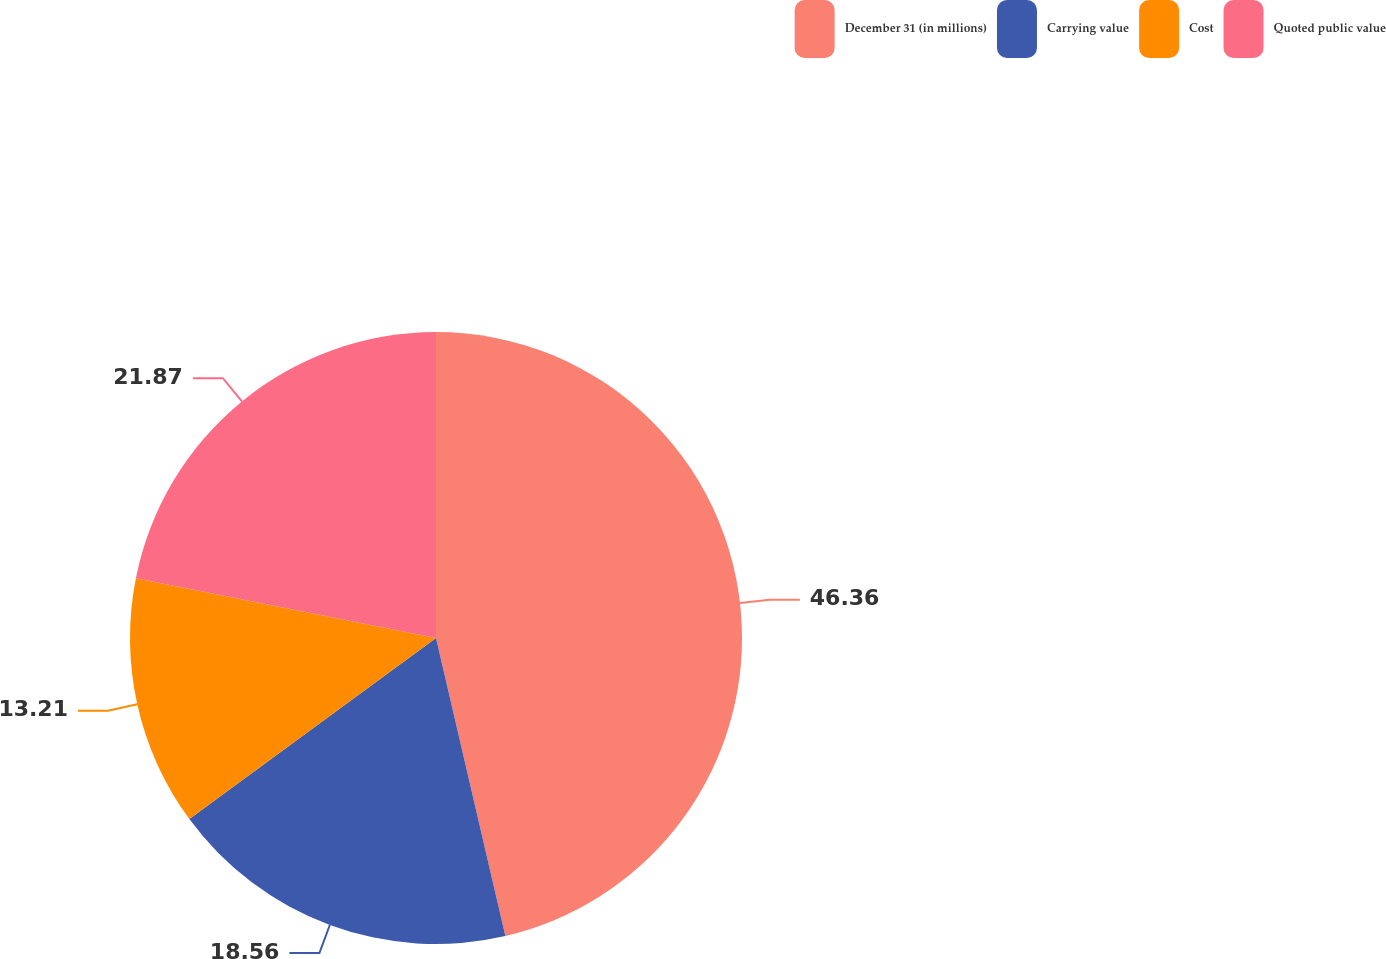Convert chart to OTSL. <chart><loc_0><loc_0><loc_500><loc_500><pie_chart><fcel>December 31 (in millions)<fcel>Carrying value<fcel>Cost<fcel>Quoted public value<nl><fcel>46.36%<fcel>18.56%<fcel>13.21%<fcel>21.87%<nl></chart> 